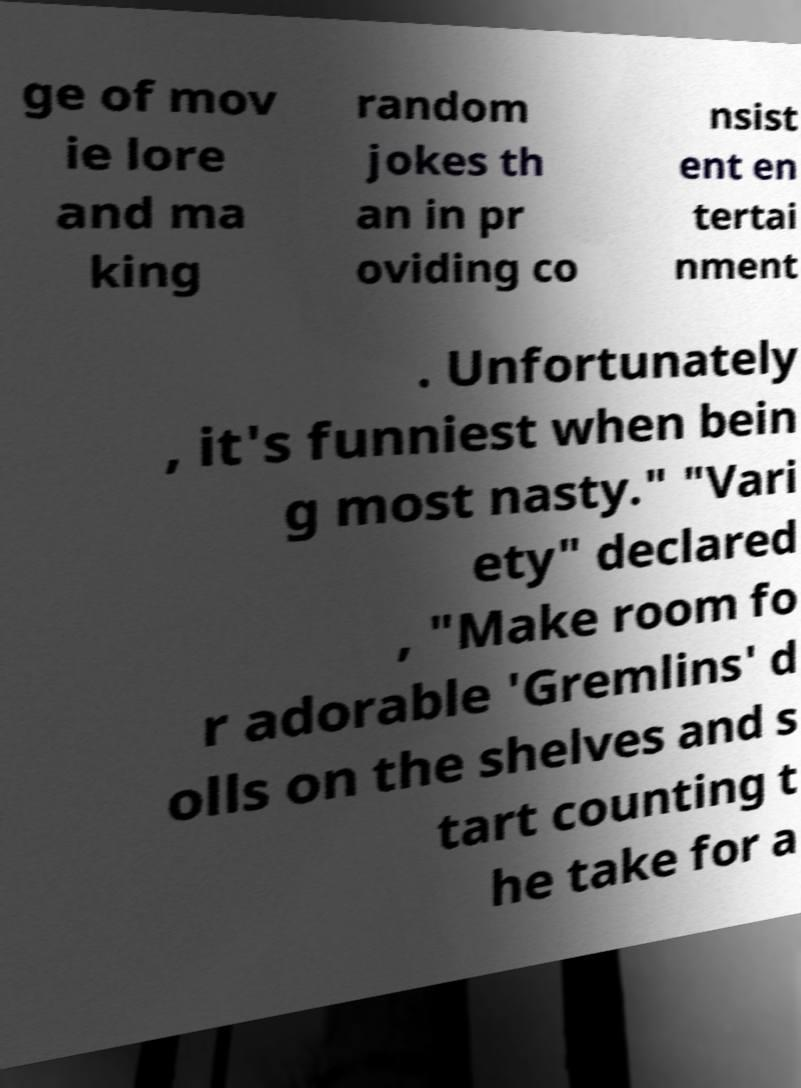I need the written content from this picture converted into text. Can you do that? ge of mov ie lore and ma king random jokes th an in pr oviding co nsist ent en tertai nment . Unfortunately , it's funniest when bein g most nasty." "Vari ety" declared , "Make room fo r adorable 'Gremlins' d olls on the shelves and s tart counting t he take for a 